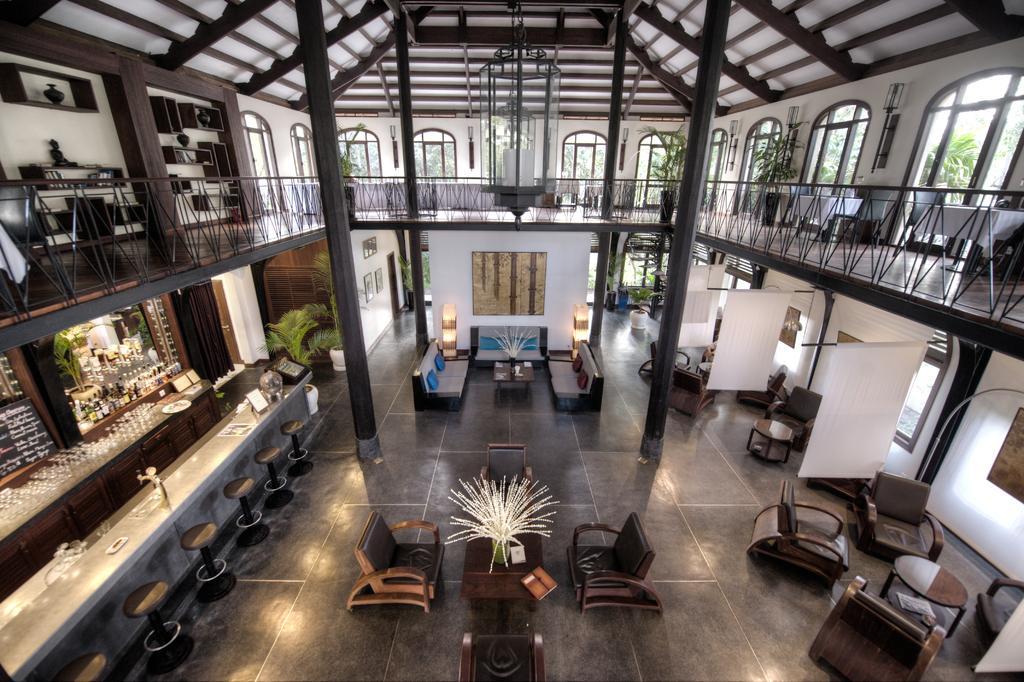Please provide a concise description of this image. In this image I can see the interior of the building in which I can see the floor, few stools, few chairs, few couches, few tables, few glasses, few plants, few pillars, the railing, few frames attached to the walls, few lights, few white colored clothes and few windows through which I can see few trees and the sky. 